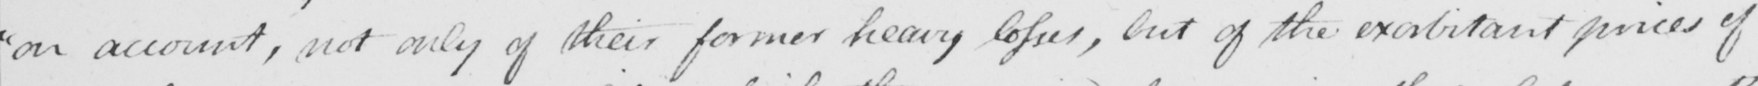What text is written in this handwritten line? " on account , not only of their former heavy losses , but of the exorbitant prices of 